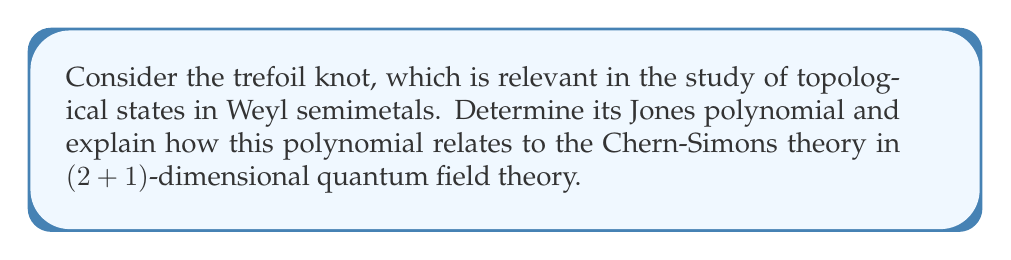Can you solve this math problem? To determine the Jones polynomial for the trefoil knot and relate it to quantum field theory, we'll follow these steps:

1. Represent the trefoil knot using a braid diagram:
   The trefoil knot can be represented by the braid word $\sigma_1^3$, where $\sigma_1$ denotes a positive crossing of the first strand over the second.

2. Calculate the Kauffman bracket polynomial:
   Let $A$ be an indeterminate. The Kauffman bracket $\langle K \rangle$ for the trefoil knot $K$ is:
   
   $$\langle K \rangle = A^7 + A^3 + A^{-1} - A^{-5}$$

3. Compute the writhe of the knot:
   The writhe $w(K)$ for the trefoil knot is +3.

4. Calculate the Jones polynomial:
   The Jones polynomial $V_K(t)$ is related to the Kauffman bracket by:
   
   $$V_K(t) = (-A^3)^{-w(K)} \langle K \rangle |_{A = t^{-1/4}}$$
   
   Substituting the values:
   
   $$V_K(t) = (-A^3)^{-3} (A^7 + A^3 + A^{-1} - A^{-5})|_{A = t^{-1/4}}$$
   
   $$V_K(t) = -t + t^3 - t^4$$

5. Relate to Chern-Simons theory:
   The Jones polynomial is intimately connected to the expectation value of Wilson loops in Chern-Simons theory. In (2+1)-dimensional quantum field theory, the Chern-Simons action is given by:
   
   $$S_{CS} = \frac{k}{4\pi} \int_{M} \text{Tr}(A \wedge dA + \frac{2}{3}A \wedge A \wedge A)$$
   
   where $k$ is the level of the theory, $A$ is the gauge field, and $M$ is a 3-manifold.

   The expectation value of a Wilson loop $W_R(K)$ in representation $R$ for a knot $K$ is:
   
   $$\langle W_R(K) \rangle = V_K(e^{2\pi i / (k+2)})$$

   This relationship demonstrates how the Jones polynomial, a topological invariant, emerges from a quantum field theory, linking knot theory to fundamental physics relevant in the study of topological states of matter, including Weyl semimetals.
Answer: $V_K(t) = -t + t^3 - t^4$ 